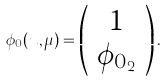Convert formula to latex. <formula><loc_0><loc_0><loc_500><loc_500>\phi _ { 0 } ( u , \mu ) = \left ( \begin{array} { c } 1 \\ \phi _ { 0 _ { 2 } } \end{array} \right ) .</formula> 